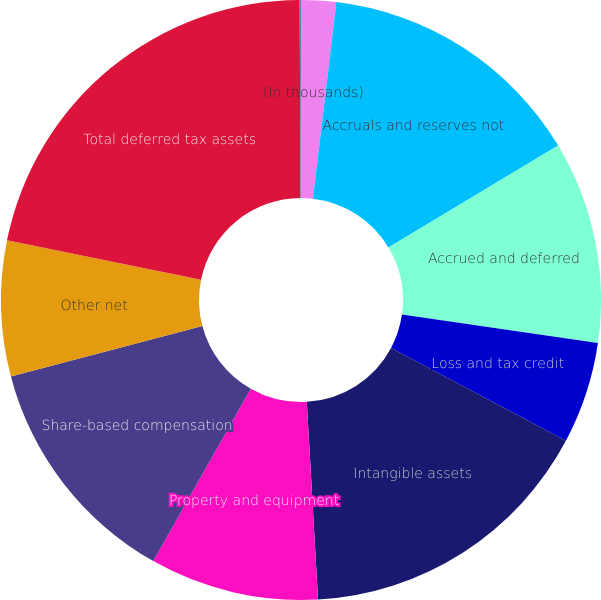Convert chart. <chart><loc_0><loc_0><loc_500><loc_500><pie_chart><fcel>(In thousands)<fcel>Accruals and reserves not<fcel>Accrued and deferred<fcel>Loss and tax credit<fcel>Intangible assets<fcel>Property and equipment<fcel>Share-based compensation<fcel>Other net<fcel>Total deferred tax assets<fcel>Total deferred tax liabilities<nl><fcel>1.88%<fcel>14.51%<fcel>10.9%<fcel>5.49%<fcel>16.32%<fcel>9.1%<fcel>12.71%<fcel>7.29%<fcel>21.74%<fcel>0.07%<nl></chart> 